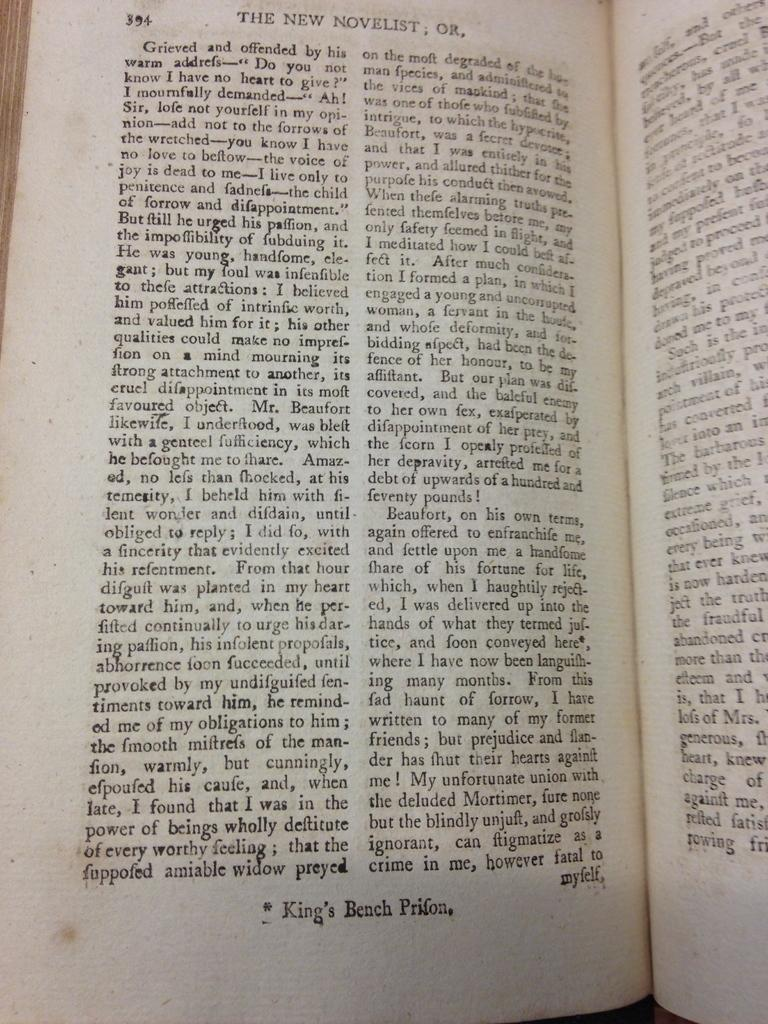<image>
Provide a brief description of the given image. A book is open to page 394 and the page begins with the words Grieved and offended by his warm addrefs. 